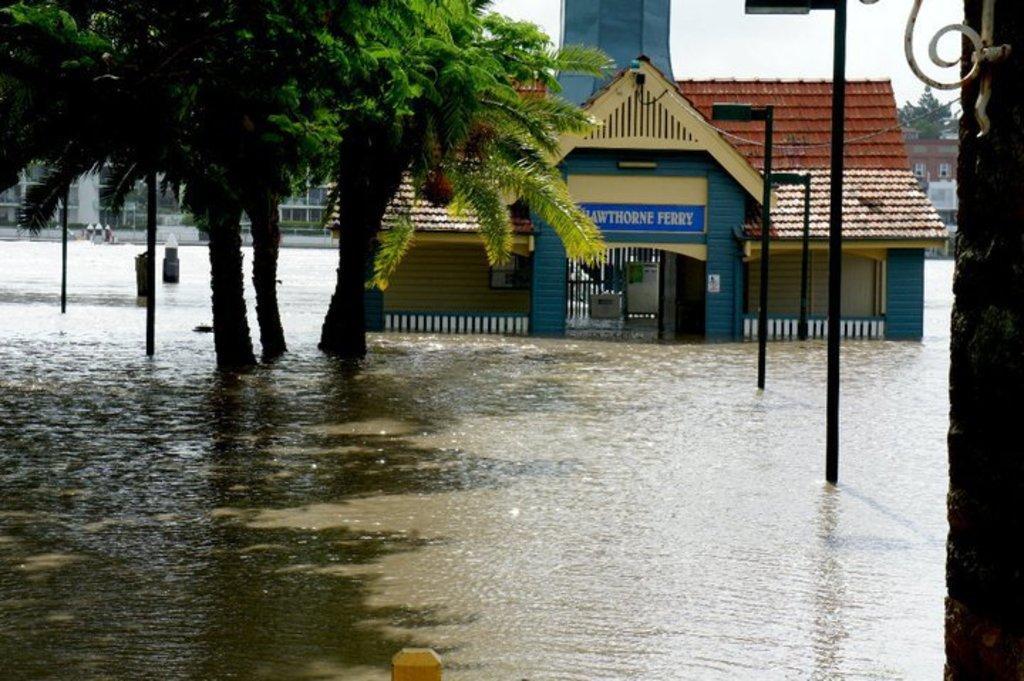Could you give a brief overview of what you see in this image? In the center of the image we can see a building with roof and tower. To the left side of the image we can see a group of trees and to the right side we can see poles. In the background, we can see a tree, building and the sky. In the foreground we can see water. 